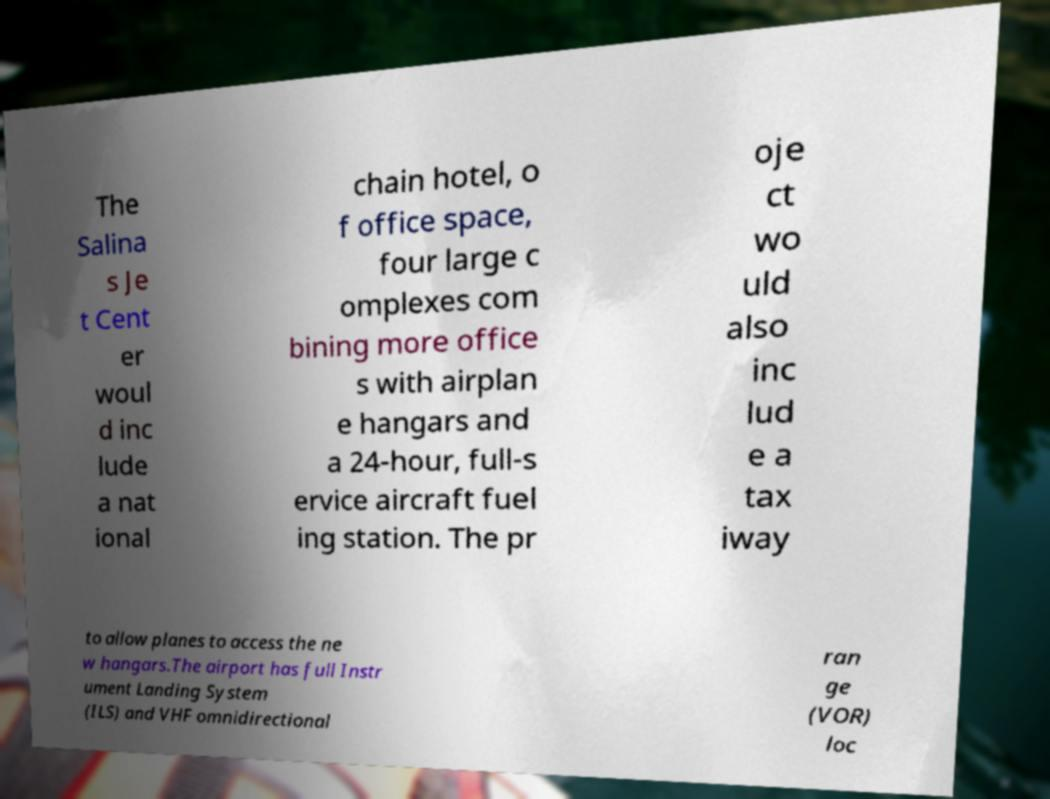There's text embedded in this image that I need extracted. Can you transcribe it verbatim? The Salina s Je t Cent er woul d inc lude a nat ional chain hotel, o f office space, four large c omplexes com bining more office s with airplan e hangars and a 24-hour, full-s ervice aircraft fuel ing station. The pr oje ct wo uld also inc lud e a tax iway to allow planes to access the ne w hangars.The airport has full Instr ument Landing System (ILS) and VHF omnidirectional ran ge (VOR) loc 